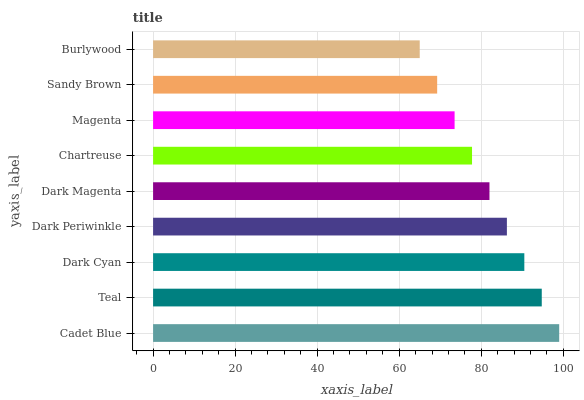Is Burlywood the minimum?
Answer yes or no. Yes. Is Cadet Blue the maximum?
Answer yes or no. Yes. Is Teal the minimum?
Answer yes or no. No. Is Teal the maximum?
Answer yes or no. No. Is Cadet Blue greater than Teal?
Answer yes or no. Yes. Is Teal less than Cadet Blue?
Answer yes or no. Yes. Is Teal greater than Cadet Blue?
Answer yes or no. No. Is Cadet Blue less than Teal?
Answer yes or no. No. Is Dark Magenta the high median?
Answer yes or no. Yes. Is Dark Magenta the low median?
Answer yes or no. Yes. Is Teal the high median?
Answer yes or no. No. Is Sandy Brown the low median?
Answer yes or no. No. 